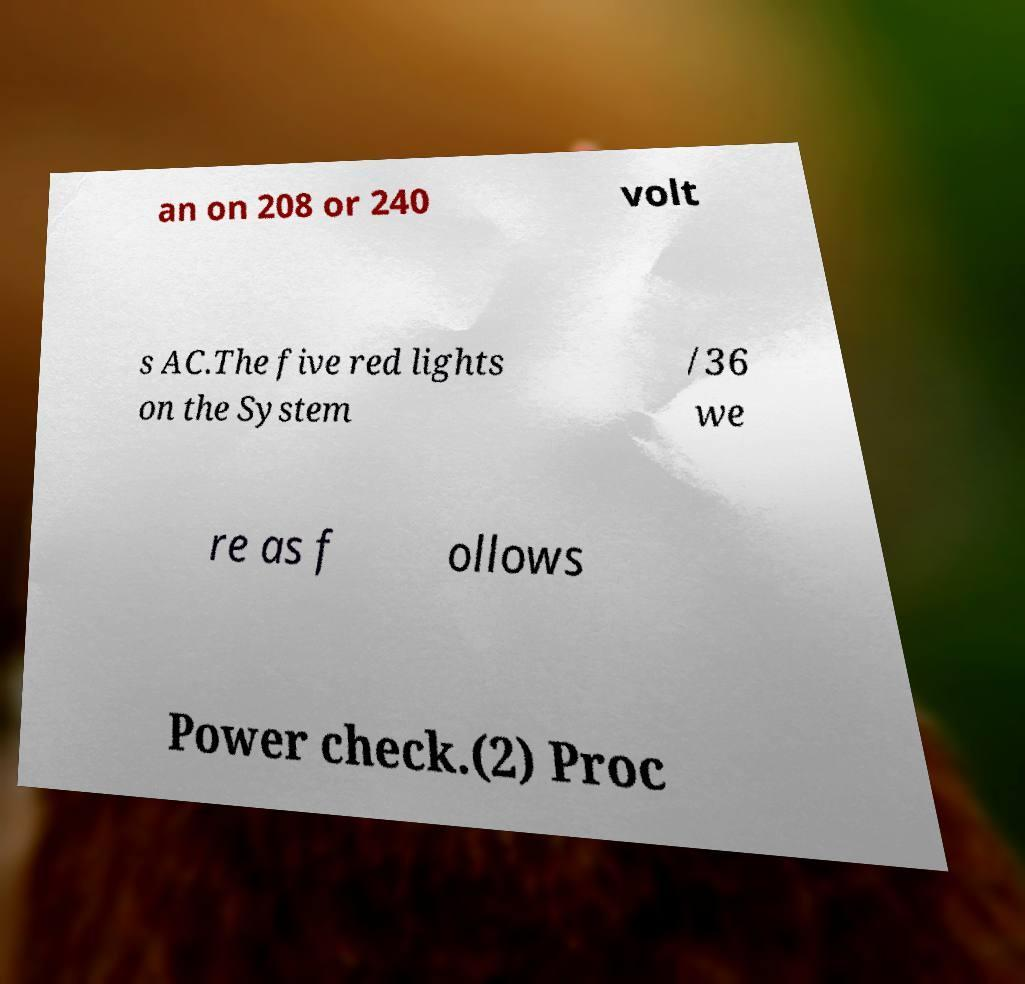Please identify and transcribe the text found in this image. an on 208 or 240 volt s AC.The five red lights on the System /36 we re as f ollows Power check.(2) Proc 